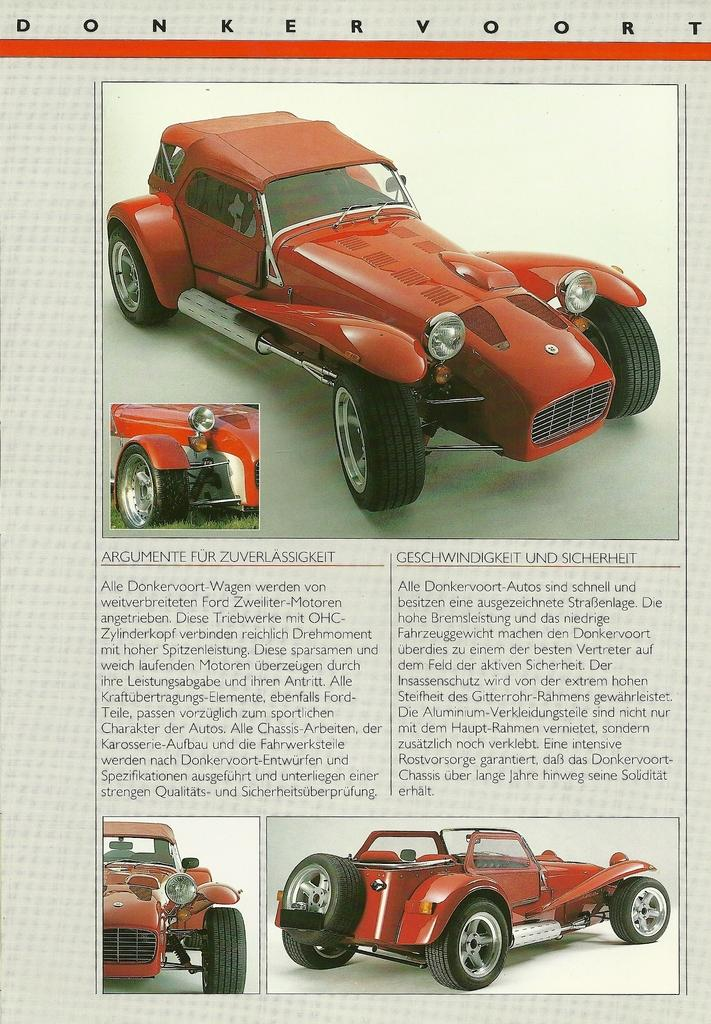What is present in the image that is related to writing or drawing? There is paper in the image. What type of images can be seen on the paper? There are pictures of a vehicle in the image. Besides the pictures, what else is featured on the paper? There is text in the image. What type of bait is being used to catch fish in the image? There is no fishing or bait present in the image; it features paper with pictures of a vehicle and text. How many degrees are visible in the image? There are no degrees present in the image. 